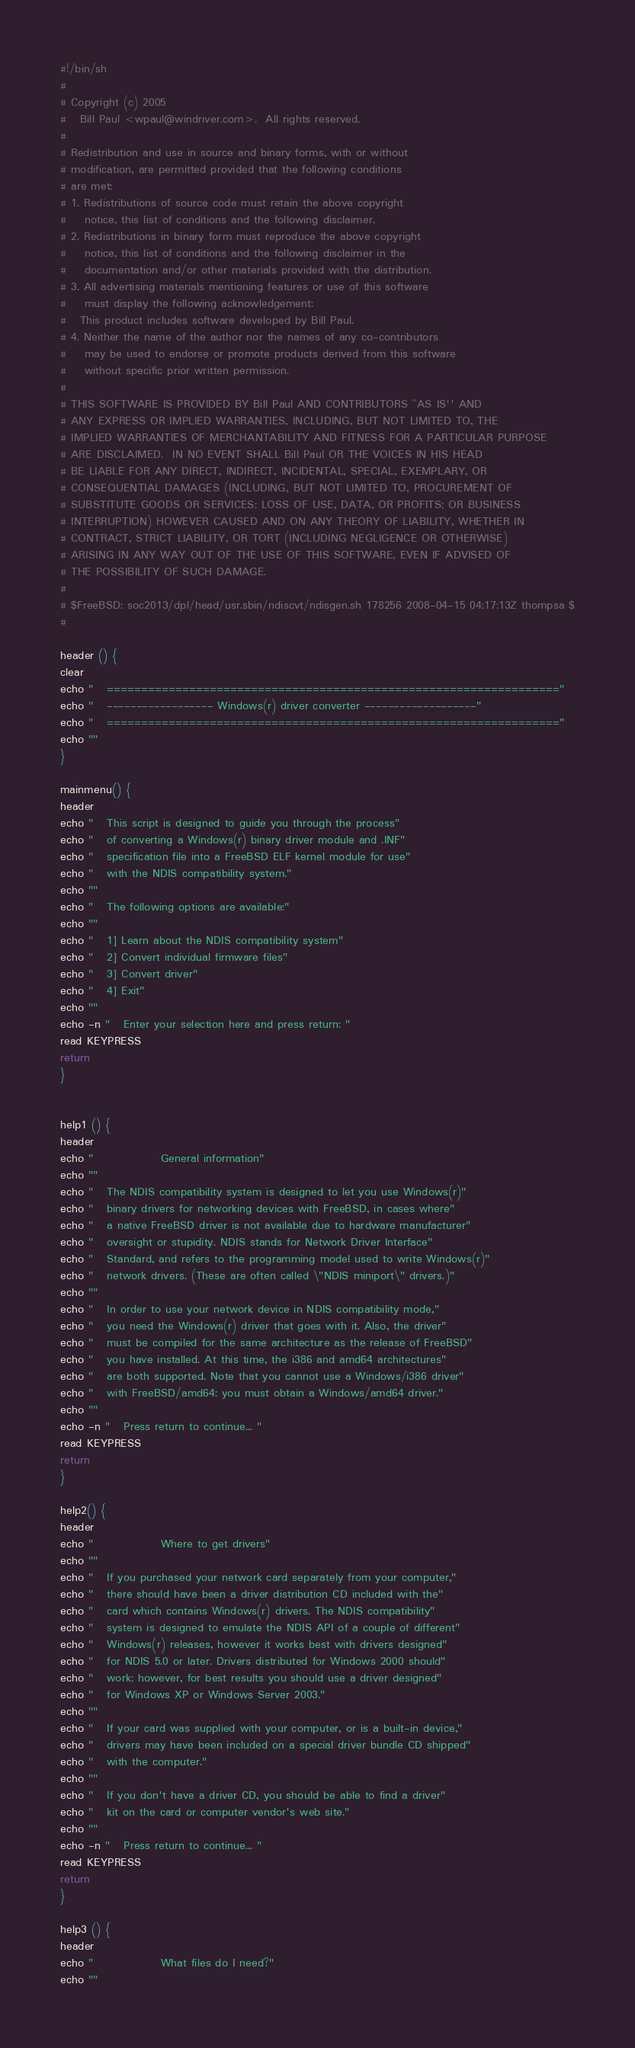<code> <loc_0><loc_0><loc_500><loc_500><_Bash_>#!/bin/sh
#
# Copyright (c) 2005
#	Bill Paul <wpaul@windriver.com>.  All rights reserved.
#
# Redistribution and use in source and binary forms, with or without
# modification, are permitted provided that the following conditions
# are met:
# 1. Redistributions of source code must retain the above copyright
#    notice, this list of conditions and the following disclaimer.
# 2. Redistributions in binary form must reproduce the above copyright
#    notice, this list of conditions and the following disclaimer in the
#    documentation and/or other materials provided with the distribution.
# 3. All advertising materials mentioning features or use of this software
#    must display the following acknowledgement:
#	This product includes software developed by Bill Paul.
# 4. Neither the name of the author nor the names of any co-contributors
#    may be used to endorse or promote products derived from this software
#    without specific prior written permission.
#
# THIS SOFTWARE IS PROVIDED BY Bill Paul AND CONTRIBUTORS ``AS IS'' AND
# ANY EXPRESS OR IMPLIED WARRANTIES, INCLUDING, BUT NOT LIMITED TO, THE
# IMPLIED WARRANTIES OF MERCHANTABILITY AND FITNESS FOR A PARTICULAR PURPOSE
# ARE DISCLAIMED.  IN NO EVENT SHALL Bill Paul OR THE VOICES IN HIS HEAD
# BE LIABLE FOR ANY DIRECT, INDIRECT, INCIDENTAL, SPECIAL, EXEMPLARY, OR
# CONSEQUENTIAL DAMAGES (INCLUDING, BUT NOT LIMITED TO, PROCUREMENT OF
# SUBSTITUTE GOODS OR SERVICES; LOSS OF USE, DATA, OR PROFITS; OR BUSINESS
# INTERRUPTION) HOWEVER CAUSED AND ON ANY THEORY OF LIABILITY, WHETHER IN
# CONTRACT, STRICT LIABILITY, OR TORT (INCLUDING NEGLIGENCE OR OTHERWISE)
# ARISING IN ANY WAY OUT OF THE USE OF THIS SOFTWARE, EVEN IF ADVISED OF
# THE POSSIBILITY OF SUCH DAMAGE.
#
# $FreeBSD: soc2013/dpl/head/usr.sbin/ndiscvt/ndisgen.sh 178256 2008-04-15 04:17:13Z thompsa $
#

header () {
clear
echo "	=================================================================="
echo "	------------------ Windows(r) driver converter -------------------"
echo "	=================================================================="
echo ""
}

mainmenu() {
header
echo "	This script is designed to guide you through the process"
echo "	of converting a Windows(r) binary driver module and .INF"
echo "	specification file into a FreeBSD ELF kernel module for use"
echo "	with the NDIS compatibility system."
echo ""
echo "	The following options are available:"
echo ""
echo "	1] Learn about the NDIS compatibility system"
echo "	2] Convert individual firmware files"
echo "	3] Convert driver"
echo "	4] Exit"
echo ""
echo -n "	Enter your selection here and press return: "
read KEYPRESS
return
}


help1 () {
header
echo "				General information"
echo ""
echo "	The NDIS compatibility system is designed to let you use Windows(r)"
echo "	binary drivers for networking devices with FreeBSD, in cases where"
echo "	a native FreeBSD driver is not available due to hardware manufacturer"
echo "	oversight or stupidity. NDIS stands for Network Driver Interface"
echo "	Standard, and refers to the programming model used to write Windows(r)"
echo "	network drivers. (These are often called \"NDIS miniport\" drivers.)"
echo ""
echo "	In order to use your network device in NDIS compatibility mode,"
echo "	you need the Windows(r) driver that goes with it. Also, the driver"
echo "	must be compiled for the same architecture as the release of FreeBSD"
echo "	you have installed. At this time, the i386 and amd64 architectures"
echo "	are both supported. Note that you cannot use a Windows/i386 driver"
echo "	with FreeBSD/amd64: you must obtain a Windows/amd64 driver."
echo ""
echo -n "	Press return to continue... "
read KEYPRESS
return
}

help2() {
header
echo "				Where to get drivers"
echo ""
echo "	If you purchased your network card separately from your computer,"
echo "	there should have been a driver distribution CD included with the"
echo "	card which contains Windows(r) drivers. The NDIS compatibility"
echo "	system is designed to emulate the NDIS API of a couple of different"
echo "	Windows(r) releases, however it works best with drivers designed"
echo "	for NDIS 5.0 or later. Drivers distributed for Windows 2000 should"
echo "	work; however, for best results you should use a driver designed"
echo "	for Windows XP or Windows Server 2003."
echo ""
echo "	If your card was supplied with your computer, or is a built-in device,"
echo "	drivers may have been included on a special driver bundle CD shipped"
echo "	with the computer."
echo ""
echo "	If you don't have a driver CD, you should be able to find a driver"
echo "	kit on the card or computer vendor's web site."
echo ""
echo -n "	Press return to continue... "
read KEYPRESS
return
}

help3 () {
header
echo "				What files do I need?"
echo ""</code> 